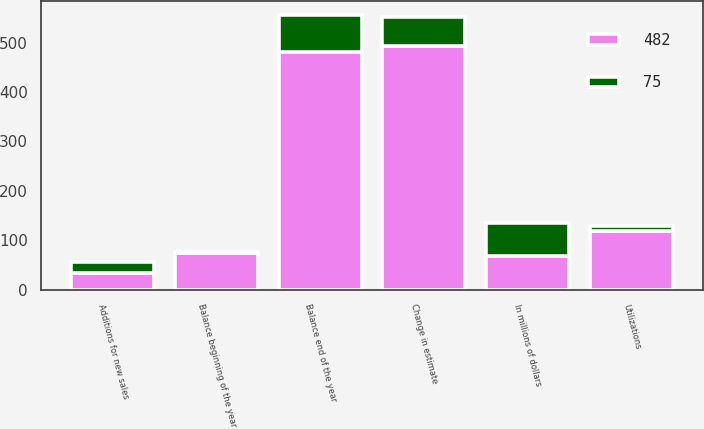<chart> <loc_0><loc_0><loc_500><loc_500><stacked_bar_chart><ecel><fcel>In millions of dollars<fcel>Balance beginning of the year<fcel>Additions for new sales<fcel>Change in estimate<fcel>Utilizations<fcel>Balance end of the year<nl><fcel>482<fcel>67<fcel>75<fcel>33<fcel>493<fcel>119<fcel>482<nl><fcel>75<fcel>67<fcel>2<fcel>23<fcel>59<fcel>9<fcel>75<nl></chart> 